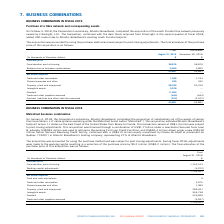According to Cogeco's financial document, When did Atlantic Broadband, completed the acquisition of the south Florida fibre network? According to the financial document, October 3, 2018. The relevant text states: "On October 3, 2018, the Corporation's subsidiary, Atlantic Broadband, completed the acquisition of the south Florida f..." Also, Which company previously owned South Florida fibre network? According to the financial document, FiberLight, LLC. The relevant text states: "e south Florida fibre network previously owned by FiberLight, LLC. The transaction, combined with the dark fibers acquired from FiberLight in the second quarter of f..." Also, Which company was acquired by Atlantic Broadband in 2018? south Florida fibre network. The document states: "antic Broadband, completed the acquisition of the south Florida fibre network previously owned by FiberLight, LLC. The transaction, combined with the ..." Also, can you calculate: What is the increase/ (decrease) in Trade and other receivables from Preliminary, November 30, 2018 to Final August 31, 2019? Based on the calculation: 1,308-1,743, the result is -435 (in thousands). This is based on the information: "Trade and other receivables 1,308 1,743 Trade and other receivables 1,308 1,743..." The key data points involved are: 1,308, 1,743. Also, can you calculate: What is the increase/ (decrease) in Property, plant and equipment from Preliminary, November 30, 2018 to Final August 31, 2019? Based on the calculation: 28,785-45,769, the result is -16984 (in thousands). This is based on the information: "Property, plant and equipment 28,785 45,769 Property, plant and equipment 28,785 45,769..." The key data points involved are: 28,785, 45,769. Also, can you calculate: What is the increase/ (decrease) in Contract liabilities and other liabilities assumed from Preliminary, November 30, 2018 to Final August 31, 2019? Based on the calculation: (-974)-(-3,322), the result is 2348 (in thousands). This is based on the information: "liabilities and other liabilities assumed (974) (3,322) ntract liabilities and other liabilities assumed (974) (3,322)..." The key data points involved are: 3,322, 974. 